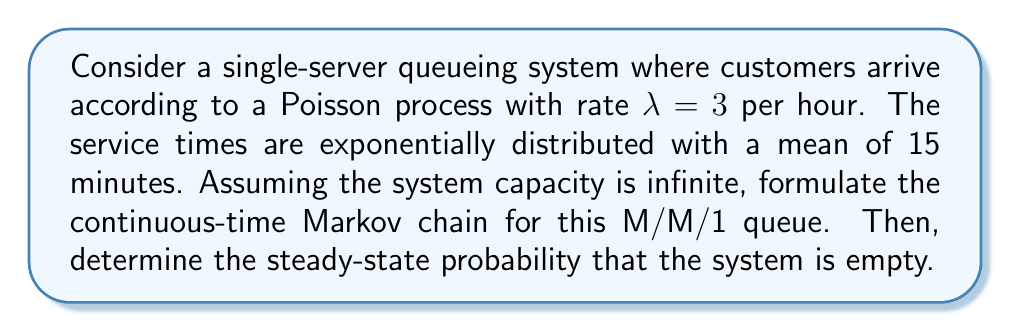What is the answer to this math problem? As a functional analyst, we can approach this problem by considering the state space and transition rates of the Markov chain:

1) First, let's define the state space. In this M/M/1 queue, the state $n$ represents the number of customers in the system (including the one being served). The state space is $S = \{0, 1, 2, ...\}$.

2) Now, let's determine the transition rates:
   - Arrival rate: $\lambda = 3$ per hour
   - Service rate: $\mu = 4$ per hour (since mean service time is 15 minutes = 1/4 hour)

3) The transition rates are:
   - From state $n$ to $n+1$: $q_{n,n+1} = \lambda = 3$ for all $n \geq 0$
   - From state $n$ to $n-1$: $q_{n,n-1} = \mu = 4$ for all $n \geq 1$

4) The infinitesimal generator matrix $Q$ for this Markov chain is:

   $$Q = \begin{bmatrix}
   -3 & 3 & 0 & 0 & \cdots \\
   4 & -7 & 3 & 0 & \cdots \\
   0 & 4 & -7 & 3 & \cdots \\
   0 & 0 & 4 & -7 & \cdots \\
   \vdots & \vdots & \vdots & \vdots & \ddots
   \end{bmatrix}$$

5) To find the steady-state probabilities, we need to solve $\pi Q = 0$ where $\pi = (\pi_0, \pi_1, \pi_2, ...)$ is the steady-state distribution.

6) For an M/M/1 queue, we know that the steady-state probabilities follow a geometric distribution:

   $$\pi_n = (1-\rho)\rho^n, \quad n \geq 0$$

   where $\rho = \lambda/\mu$ is the traffic intensity.

7) In this case, $\rho = 3/4 = 0.75$

8) Therefore, the probability that the system is empty (i.e., in state 0) is:

   $$\pi_0 = 1 - \rho = 1 - 0.75 = 0.25$$
Answer: The steady-state probability that the system is empty is 0.25 or 25%. 